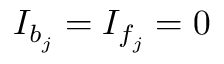<formula> <loc_0><loc_0><loc_500><loc_500>I _ { b _ { j } } = I _ { f _ { j } } = 0</formula> 